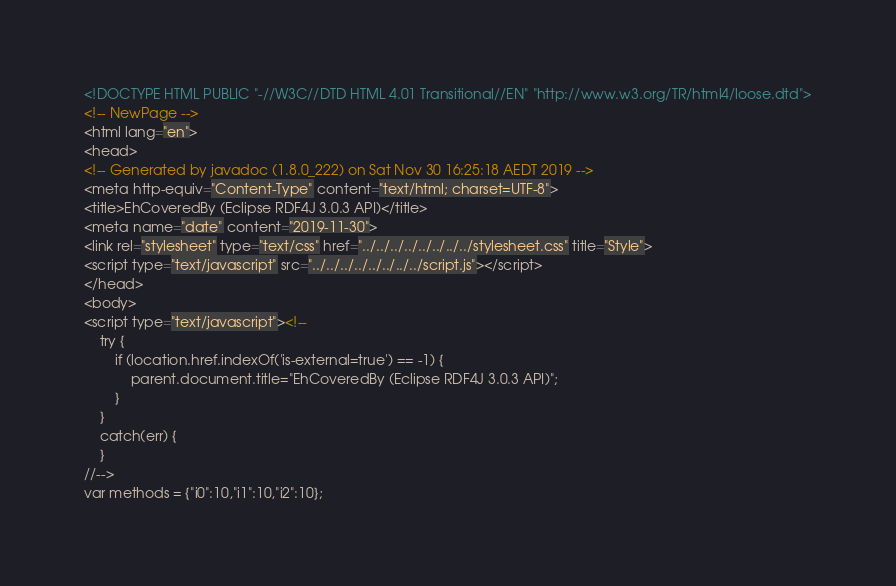<code> <loc_0><loc_0><loc_500><loc_500><_HTML_><!DOCTYPE HTML PUBLIC "-//W3C//DTD HTML 4.01 Transitional//EN" "http://www.w3.org/TR/html4/loose.dtd">
<!-- NewPage -->
<html lang="en">
<head>
<!-- Generated by javadoc (1.8.0_222) on Sat Nov 30 16:25:18 AEDT 2019 -->
<meta http-equiv="Content-Type" content="text/html; charset=UTF-8">
<title>EhCoveredBy (Eclipse RDF4J 3.0.3 API)</title>
<meta name="date" content="2019-11-30">
<link rel="stylesheet" type="text/css" href="../../../../../../../../stylesheet.css" title="Style">
<script type="text/javascript" src="../../../../../../../../script.js"></script>
</head>
<body>
<script type="text/javascript"><!--
    try {
        if (location.href.indexOf('is-external=true') == -1) {
            parent.document.title="EhCoveredBy (Eclipse RDF4J 3.0.3 API)";
        }
    }
    catch(err) {
    }
//-->
var methods = {"i0":10,"i1":10,"i2":10};</code> 